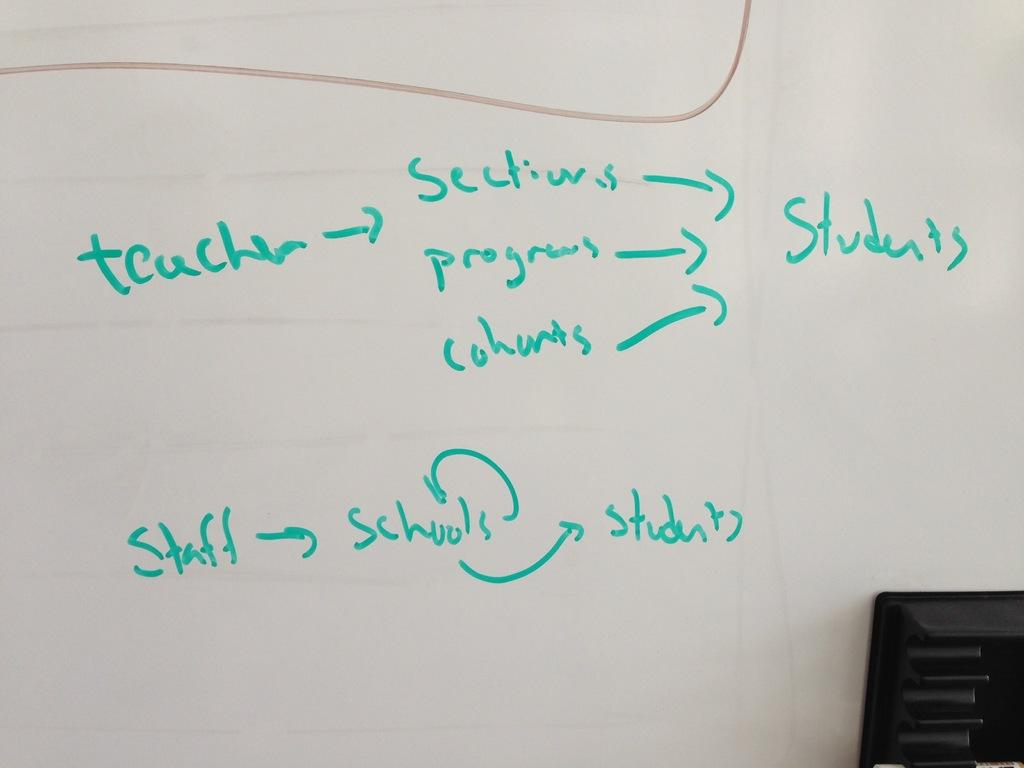<image>
Render a clear and concise summary of the photo. Text including teacher and staff on a whiteboard. 